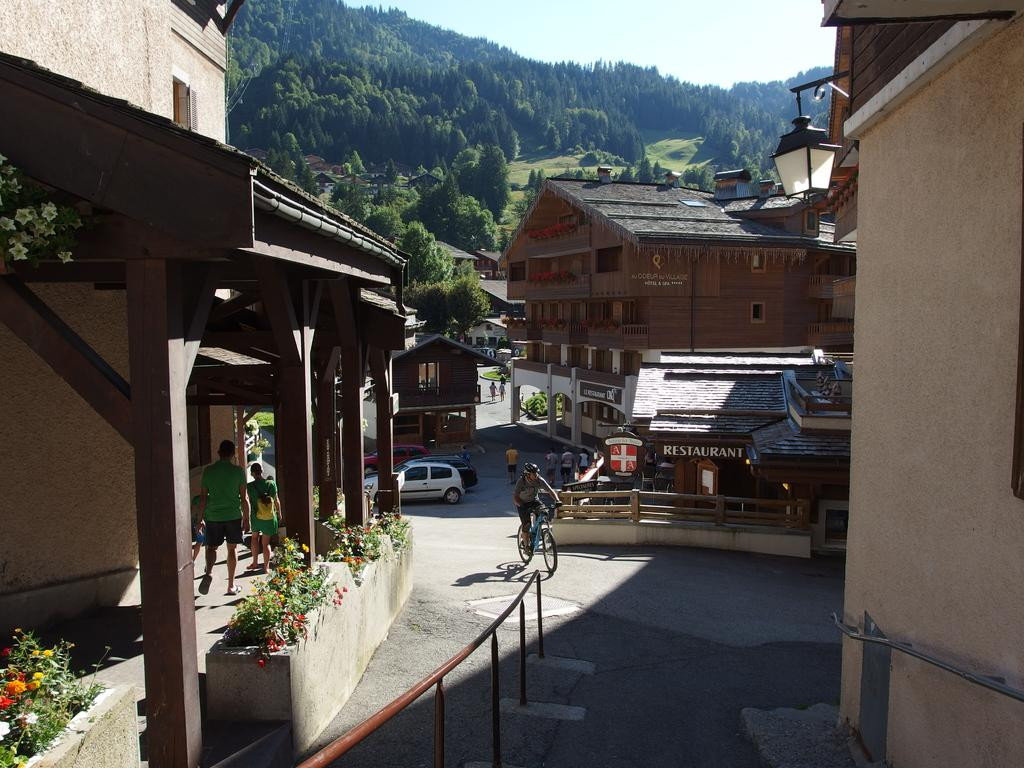<image>
Provide a brief description of the given image. walkway leading down to a restaurant and several other buildings 